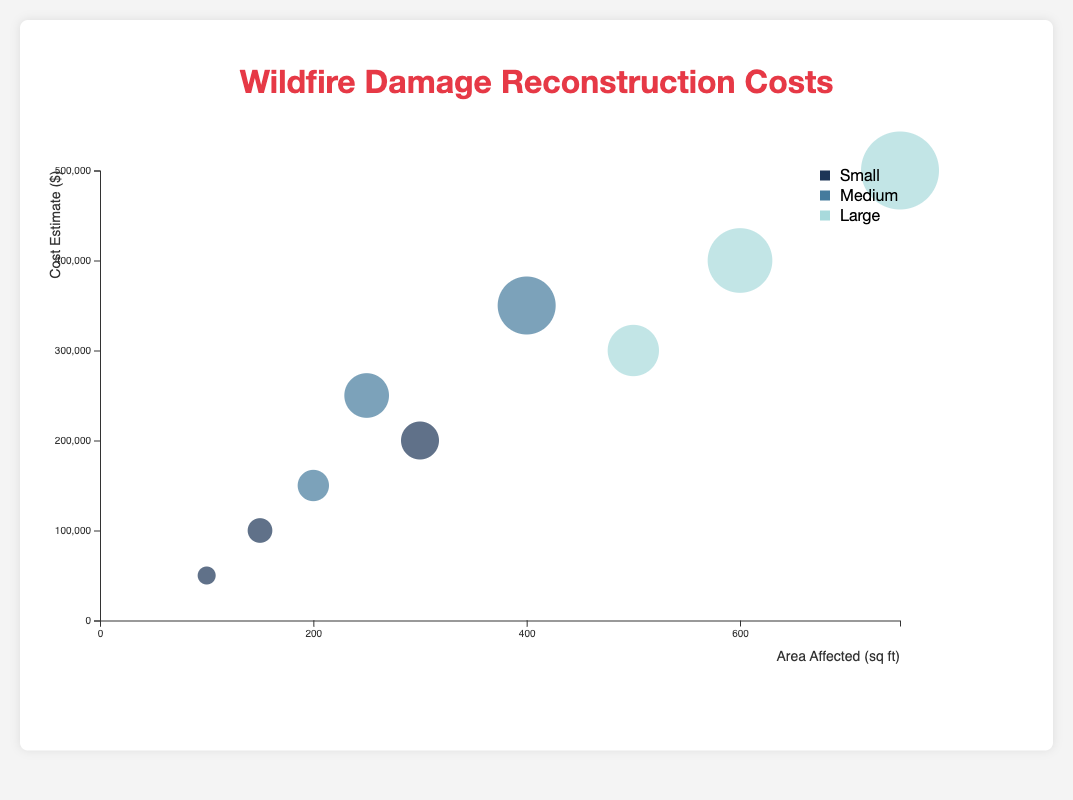What are the axis labels in the figure? The x-axis represents the "Area Affected" in square feet, and the y-axis represents the "Cost Estimate" in dollars. The axis labels help identify what each axis measures in the chart.
Answer: "Area Affected (sq ft)" and "Cost Estimate ($)" How many data points are shown in the chart? Each bubble in the chart represents a data point. By counting the bubbles, we can determine the total number of data points.
Answer: 9 What's the cost estimate for the medium-sized house with moderate damage in Colorado? Locate the bubble corresponding to "Medium" house size and "Moderate" damage extent for Colorado. The tooltip reveals that its cost estimate is $250,000.
Answer: $250,000 Which house size has the highest reconstruction cost estimate? By looking at the y-axis (Cost Estimate) and the largest bubbles, we find that the large-sized house with severe damage has the highest cost, which is $500,000.
Answer: Large What is the average "Area Affected" for small-sized houses? Sum the area affected for small-sized houses (100 + 150 + 300), then divide by the number of data points (3). The average is (100 + 150 + 300) / 3 = 183.33 sq ft.
Answer: 183.33 sq ft Which combination of house size and damage extent has the smallest cost estimate? Find the smallest bubble on the chart. The tooltip for the smallest bubble indicates a small house with minor damage has the smallest cost estimate of $50,000.
Answer: Small house with minor damage How does the cost estimate for large houses compare to that of small houses? Compare the cost estimates vertically (along the y-axis) for large-sized houses and small-sized houses. Large houses have cost estimates ranging from $300,000 to $500,000, while small houses range from $50,000 to $200,000, indicating large houses are more expensive to reconstruct on average.
Answer: Large houses cost more on average What is the relationship between the area affected and the cost estimate? By observing the chart, there is a positive correlation: as the area affected increases, the cost estimate tends to increase. This can be inferred by the general upward trend from left to right.
Answer: Positive correlation What can you infer about the reconstruction costs in different states? By examining the color-coded bubbles and their locations, we can infer that larger houses in Texas have higher reconstruction costs, medium houses in Colorado have moderate costs, and smaller houses in California have relatively lower costs.
Answer: Costs are highest in Texas, moderate in Colorado, and lowest in California 